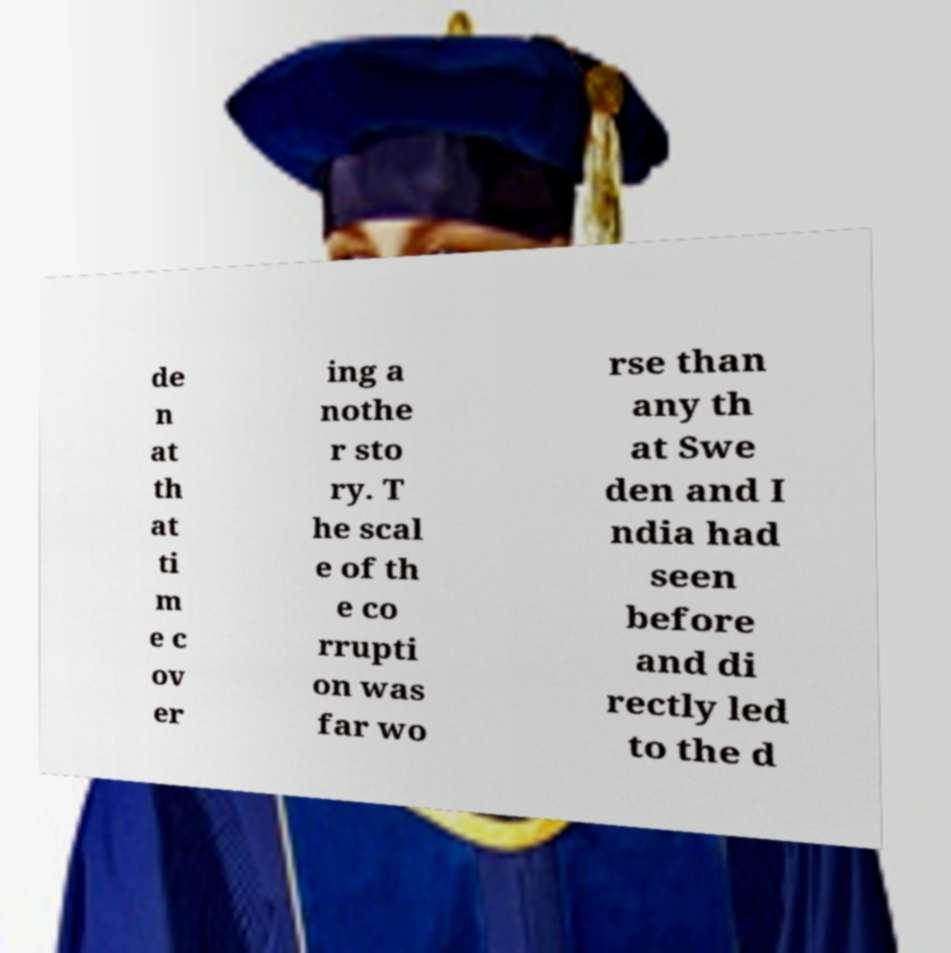I need the written content from this picture converted into text. Can you do that? de n at th at ti m e c ov er ing a nothe r sto ry. T he scal e of th e co rrupti on was far wo rse than any th at Swe den and I ndia had seen before and di rectly led to the d 